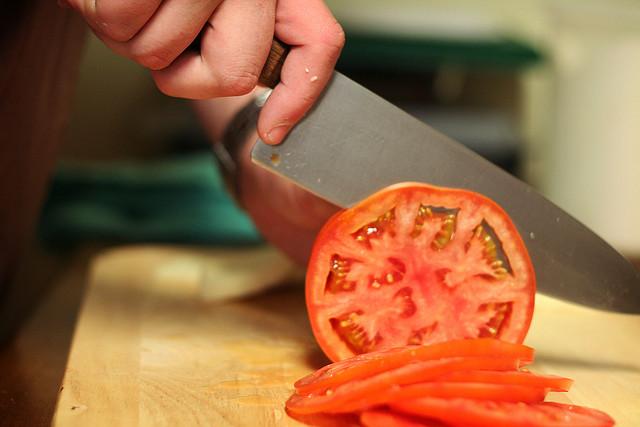What is under the tomato?
Write a very short answer. Cutting board. How is the veggies being cut?
Keep it brief. Knife. What is the knife cutting?
Short answer required. Tomato. What is holding the knife?
Answer briefly. Hand. 